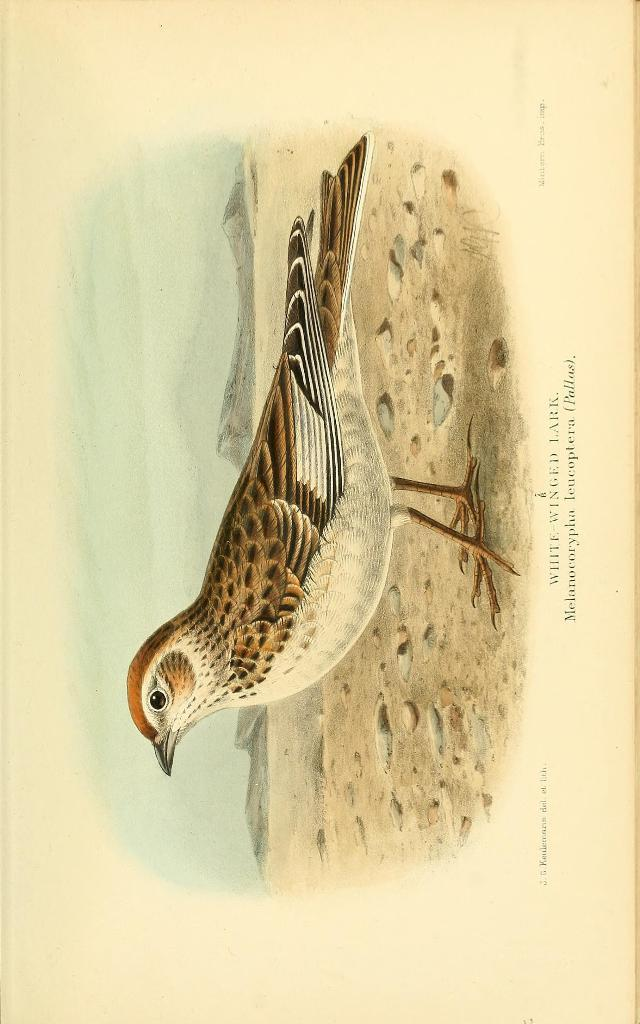What is depicted on the ground in the image? There is a picture of a bird on the ground in the image. What else can be seen in the image besides the bird? There is text visible on the image. What type of ear can be seen on the bird in the image? There is no ear visible on the bird in the image, as birds do not have external ears like mammals. 